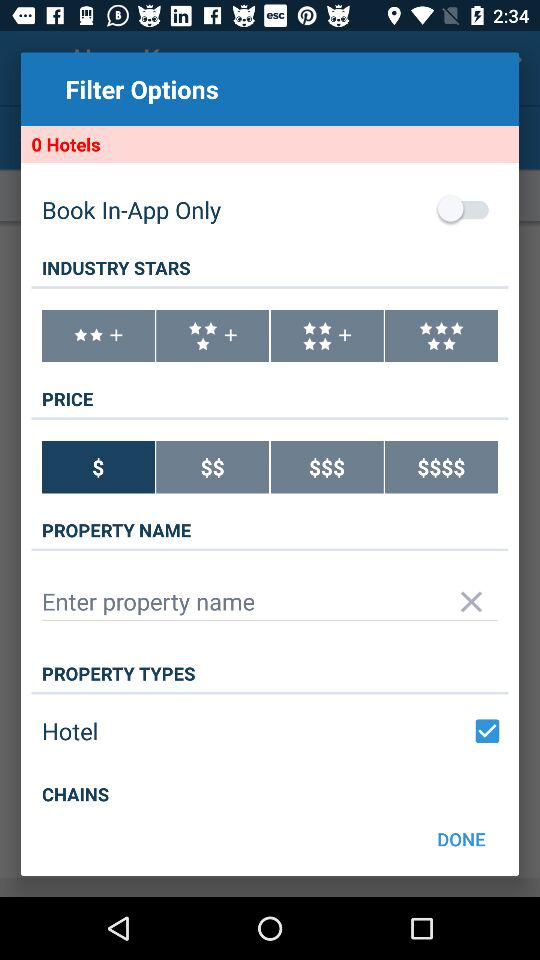How many more property types options are there than chains options?
Answer the question using a single word or phrase. 1 